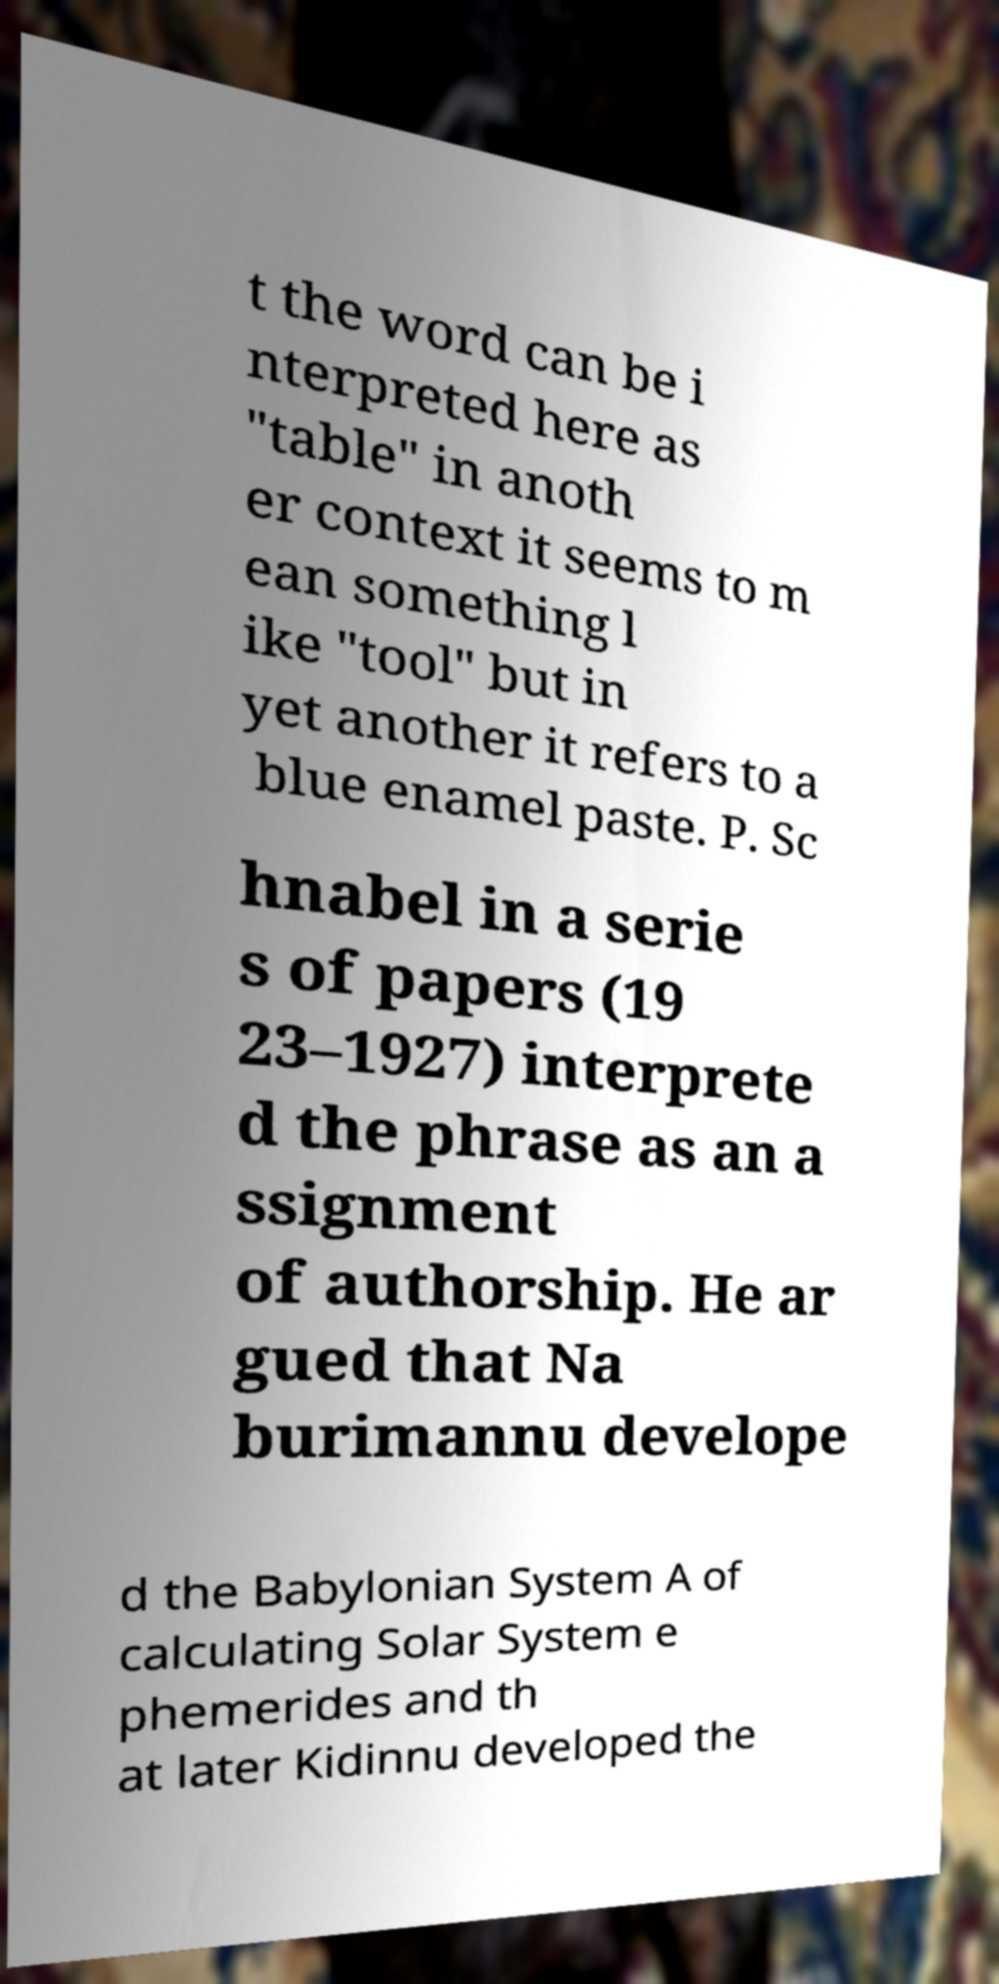Can you accurately transcribe the text from the provided image for me? t the word can be i nterpreted here as "table" in anoth er context it seems to m ean something l ike "tool" but in yet another it refers to a blue enamel paste. P. Sc hnabel in a serie s of papers (19 23–1927) interprete d the phrase as an a ssignment of authorship. He ar gued that Na burimannu develope d the Babylonian System A of calculating Solar System e phemerides and th at later Kidinnu developed the 